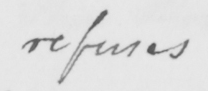What text is written in this handwritten line? refuses 